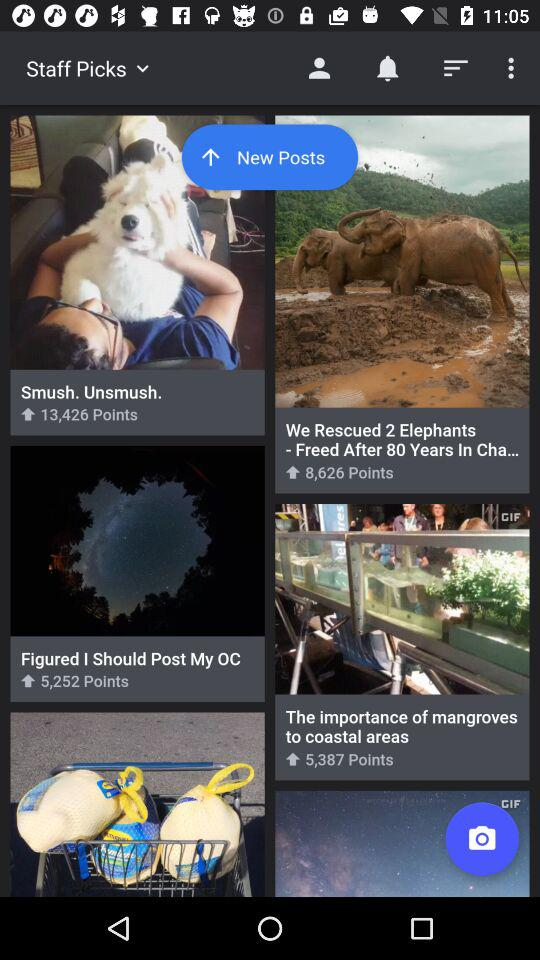How many points does "Smush. Unsmush." have? "Smush. Unsmush." have 13,426 points. 